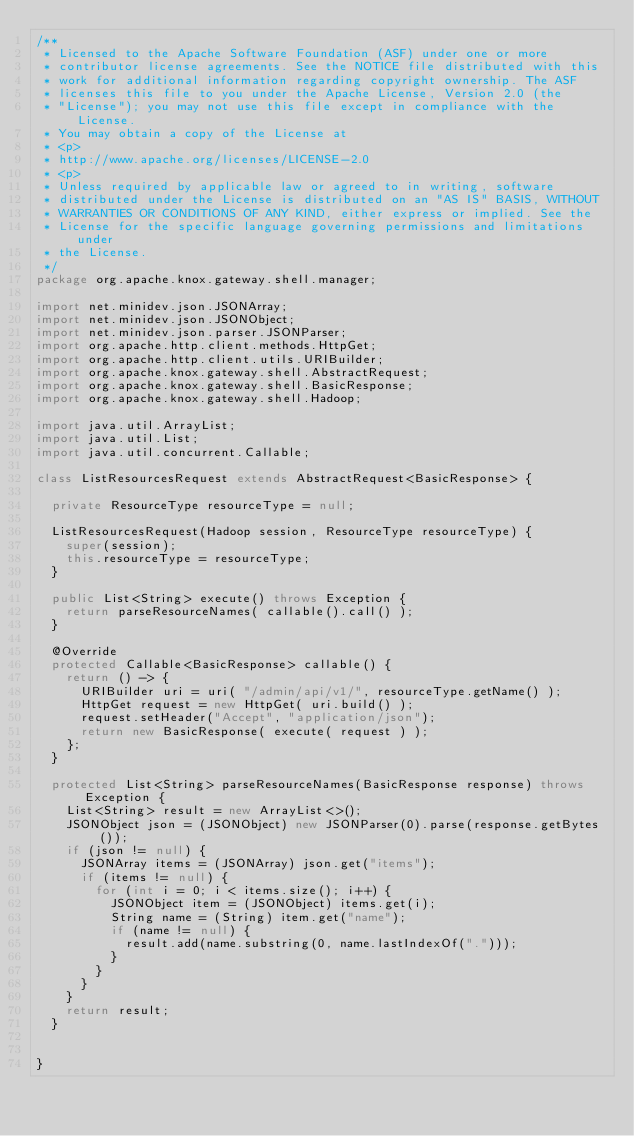<code> <loc_0><loc_0><loc_500><loc_500><_Java_>/**
 * Licensed to the Apache Software Foundation (ASF) under one or more
 * contributor license agreements. See the NOTICE file distributed with this
 * work for additional information regarding copyright ownership. The ASF
 * licenses this file to you under the Apache License, Version 2.0 (the
 * "License"); you may not use this file except in compliance with the License.
 * You may obtain a copy of the License at
 * <p>
 * http://www.apache.org/licenses/LICENSE-2.0
 * <p>
 * Unless required by applicable law or agreed to in writing, software
 * distributed under the License is distributed on an "AS IS" BASIS, WITHOUT
 * WARRANTIES OR CONDITIONS OF ANY KIND, either express or implied. See the
 * License for the specific language governing permissions and limitations under
 * the License.
 */
package org.apache.knox.gateway.shell.manager;

import net.minidev.json.JSONArray;
import net.minidev.json.JSONObject;
import net.minidev.json.parser.JSONParser;
import org.apache.http.client.methods.HttpGet;
import org.apache.http.client.utils.URIBuilder;
import org.apache.knox.gateway.shell.AbstractRequest;
import org.apache.knox.gateway.shell.BasicResponse;
import org.apache.knox.gateway.shell.Hadoop;

import java.util.ArrayList;
import java.util.List;
import java.util.concurrent.Callable;

class ListResourcesRequest extends AbstractRequest<BasicResponse> {

  private ResourceType resourceType = null;

  ListResourcesRequest(Hadoop session, ResourceType resourceType) {
    super(session);
    this.resourceType = resourceType;
  }

  public List<String> execute() throws Exception {
    return parseResourceNames( callable().call() );
  }

  @Override
  protected Callable<BasicResponse> callable() {
    return () -> {
      URIBuilder uri = uri( "/admin/api/v1/", resourceType.getName() );
      HttpGet request = new HttpGet( uri.build() );
      request.setHeader("Accept", "application/json");
      return new BasicResponse( execute( request ) );
    };
  }

  protected List<String> parseResourceNames(BasicResponse response) throws Exception {
    List<String> result = new ArrayList<>();
    JSONObject json = (JSONObject) new JSONParser(0).parse(response.getBytes());
    if (json != null) {
      JSONArray items = (JSONArray) json.get("items");
      if (items != null) {
        for (int i = 0; i < items.size(); i++) {
          JSONObject item = (JSONObject) items.get(i);
          String name = (String) item.get("name");
          if (name != null) {
            result.add(name.substring(0, name.lastIndexOf(".")));
          }
        }
      }
    }
    return result;
  }


}
</code> 